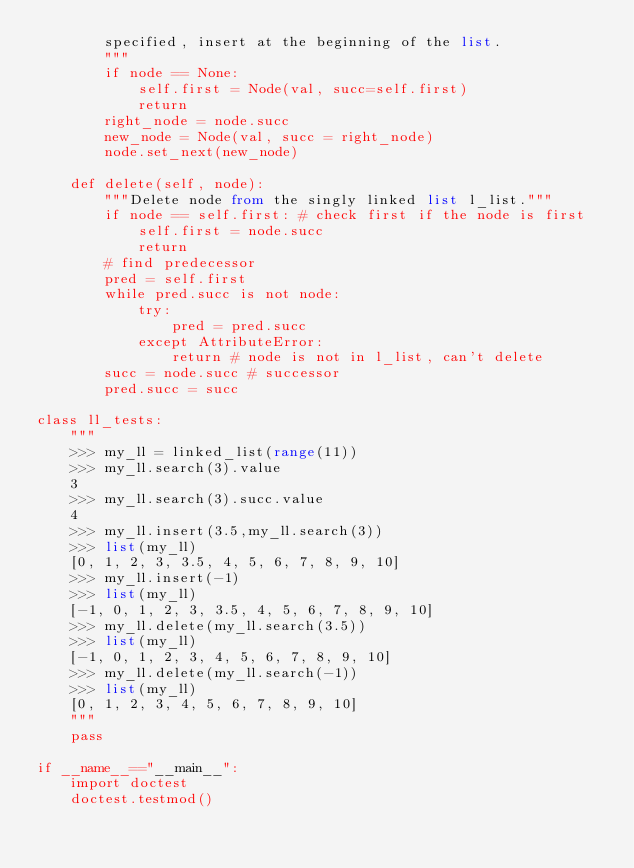Convert code to text. <code><loc_0><loc_0><loc_500><loc_500><_Python_>        specified, insert at the beginning of the list.
        """
        if node == None:
            self.first = Node(val, succ=self.first)
            return
        right_node = node.succ
        new_node = Node(val, succ = right_node)
        node.set_next(new_node)

    def delete(self, node):
        """Delete node from the singly linked list l_list."""
        if node == self.first: # check first if the node is first
            self.first = node.succ
            return
        # find predecessor
        pred = self.first
        while pred.succ is not node:
            try: 
                pred = pred.succ
            except AttributeError:
                return # node is not in l_list, can't delete
        succ = node.succ # successor
        pred.succ = succ

class ll_tests:
    """
    >>> my_ll = linked_list(range(11))
    >>> my_ll.search(3).value
    3
    >>> my_ll.search(3).succ.value
    4
    >>> my_ll.insert(3.5,my_ll.search(3))
    >>> list(my_ll)
    [0, 1, 2, 3, 3.5, 4, 5, 6, 7, 8, 9, 10]
    >>> my_ll.insert(-1)
    >>> list(my_ll)
    [-1, 0, 1, 2, 3, 3.5, 4, 5, 6, 7, 8, 9, 10]
    >>> my_ll.delete(my_ll.search(3.5))
    >>> list(my_ll)
    [-1, 0, 1, 2, 3, 4, 5, 6, 7, 8, 9, 10]
    >>> my_ll.delete(my_ll.search(-1))
    >>> list(my_ll)
    [0, 1, 2, 3, 4, 5, 6, 7, 8, 9, 10]
    """
    pass

if __name__=="__main__":
    import doctest
    doctest.testmod()
</code> 